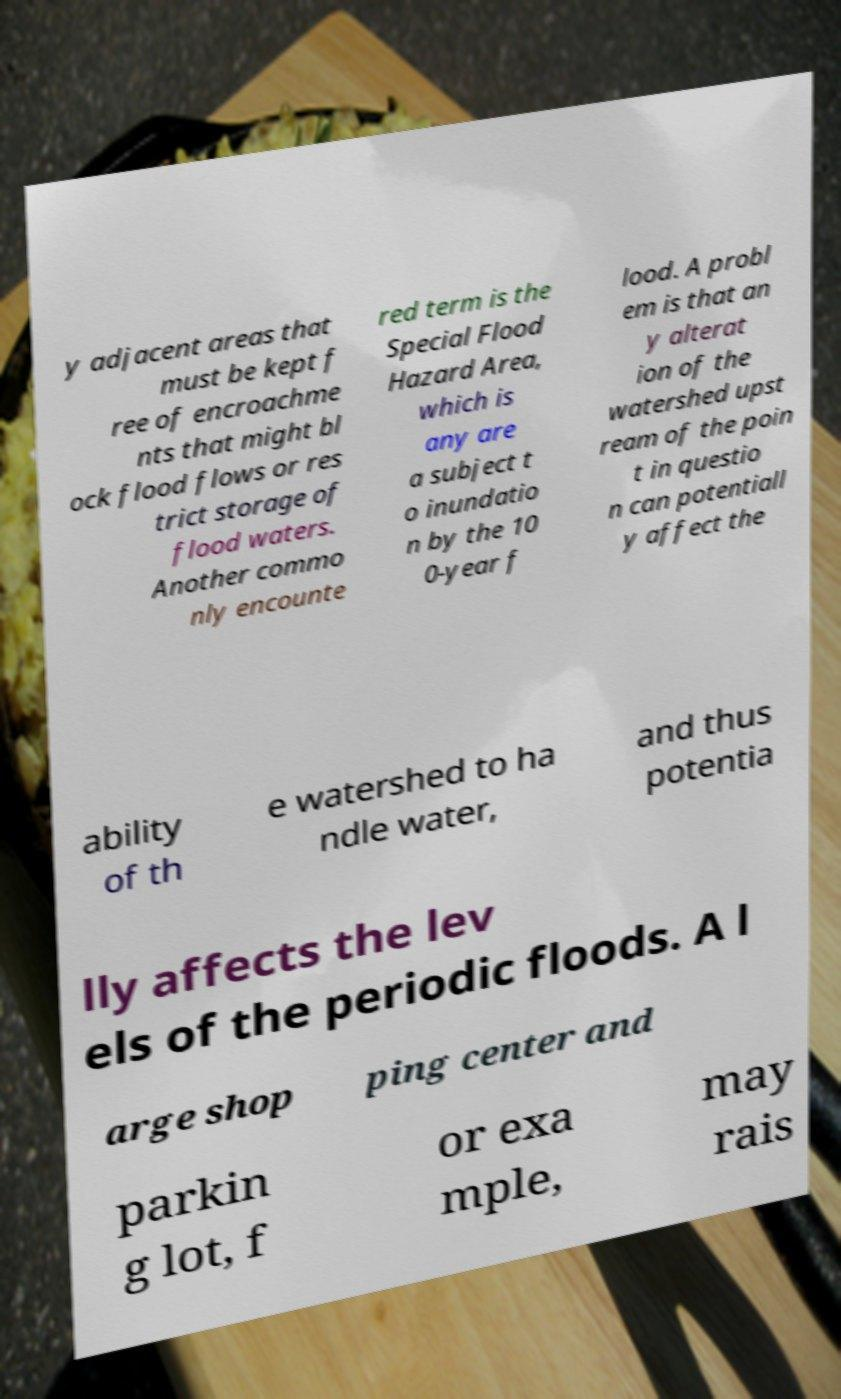There's text embedded in this image that I need extracted. Can you transcribe it verbatim? y adjacent areas that must be kept f ree of encroachme nts that might bl ock flood flows or res trict storage of flood waters. Another commo nly encounte red term is the Special Flood Hazard Area, which is any are a subject t o inundatio n by the 10 0-year f lood. A probl em is that an y alterat ion of the watershed upst ream of the poin t in questio n can potentiall y affect the ability of th e watershed to ha ndle water, and thus potentia lly affects the lev els of the periodic floods. A l arge shop ping center and parkin g lot, f or exa mple, may rais 